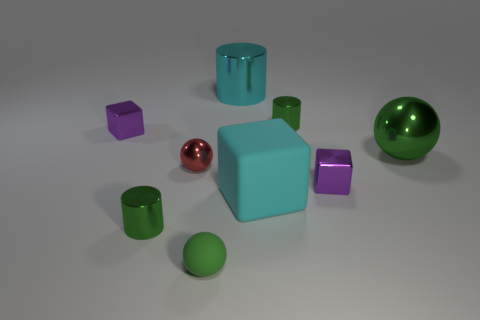What is the shape of the object that is the same color as the large cube?
Keep it short and to the point. Cylinder. There is a purple metallic cube behind the large green metallic thing; is there a small sphere that is to the left of it?
Your answer should be very brief. No. Is there any other thing that is the same color as the rubber block?
Provide a short and direct response. Yes. Is the green sphere behind the cyan rubber object made of the same material as the cyan block?
Keep it short and to the point. No. Is the number of large spheres behind the matte sphere the same as the number of green things that are in front of the big green shiny thing?
Provide a succinct answer. No. There is a green shiny thing that is right of the small purple object that is to the right of the cyan metal cylinder; what is its size?
Ensure brevity in your answer.  Large. What material is the block that is both right of the small green matte object and behind the matte cube?
Offer a terse response. Metal. How many other objects are there of the same size as the matte cube?
Offer a very short reply. 2. What is the color of the big ball?
Keep it short and to the point. Green. There is a metallic ball on the left side of the large green metal object; does it have the same color as the block to the left of the tiny red sphere?
Provide a short and direct response. No. 